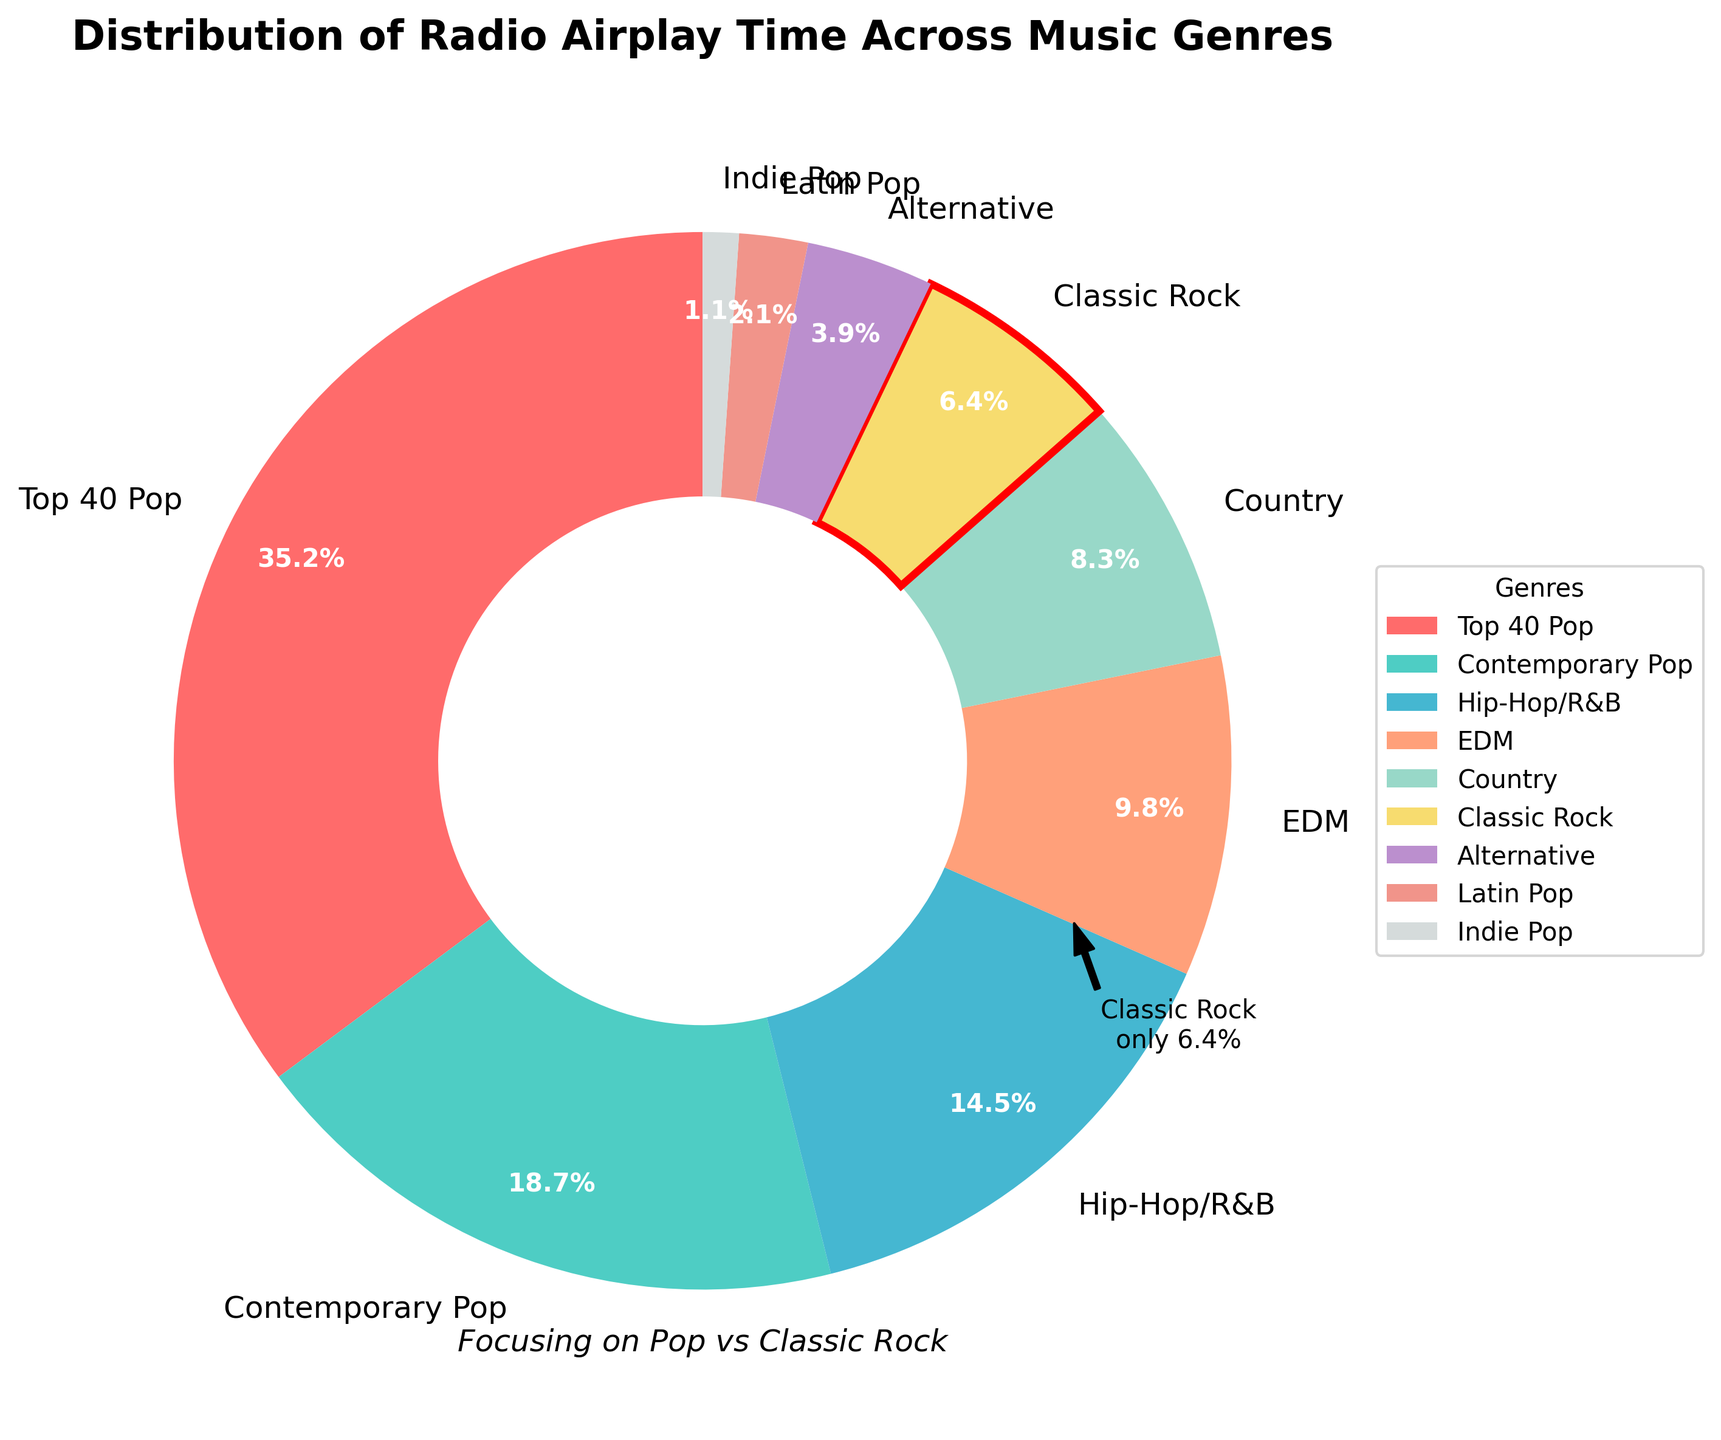What genre has the highest airplay percentage? The biggest slice on the chart represents Top 40 Pop with 35.2% airplay.
Answer: Top 40 Pop What's the difference in airplay percentage between Top 40 Pop and Classic Rock? Top 40 Pop has 35.2% and Classic Rock has 6.4%. The difference is 35.2% - 6.4% = 28.8%.
Answer: 28.8% How many genres have an airplay percentage greater than Classic Rock? Referring to the chart, the genres with higher airplay percentages than Classic Rock (6.4%) are Top 40 Pop, Contemporary Pop, Hip-Hop/R&B, EDM, and Country. That's 5 genres.
Answer: 5 What is the combined airplay percentage of all Pop genres (Top 40 Pop, Contemporary Pop, Indie Pop)? Add the percentages: 35.2% (Top 40 Pop) + 18.7% (Contemporary Pop) + 1.1% (Indie Pop) = 55.0%.
Answer: 55.0% Which genre has the lowest airplay percentage? The smallest slice on the chart belongs to Indie Pop with 1.1%.
Answer: Indie Pop Is Classic Rock among the top three most played genres? The top three genres by airplay percentage are Top 40 Pop, Contemporary Pop, and Hip-Hop/R&B. Classic Rock is not in the top three.
Answer: No How much more airplay time does Top 40 Pop receive compared to EDM? Top 40 Pop has 35.2% and EDM has 9.8%. The difference is 35.2% - 9.8% = 25.4%.
Answer: 25.4% What is the percentage of airplay time for non-Pop genres combined (excluding Top 40 Pop, Contemporary Pop, and Indie Pop)? Add the percentages for all non-Pop genres: 14.5% (Hip-Hop/R&B) + 9.8% (EDM) + 8.3% (Country) + 6.4% (Classic Rock) + 3.9% (Alternative) + 2.1% (Latin Pop) = 45.0%.
Answer: 45.0% Which genre's slice is highlighted with an edge color? The Classic Rock genre (6.4%) slice is highlighted with a red edge.
Answer: Classic Rock 